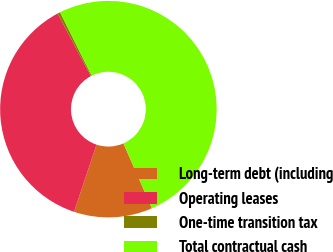<chart> <loc_0><loc_0><loc_500><loc_500><pie_chart><fcel>Long-term debt (including<fcel>Operating leases<fcel>One-time transition tax<fcel>Total contractual cash<nl><fcel>11.72%<fcel>37.11%<fcel>0.39%<fcel>50.77%<nl></chart> 